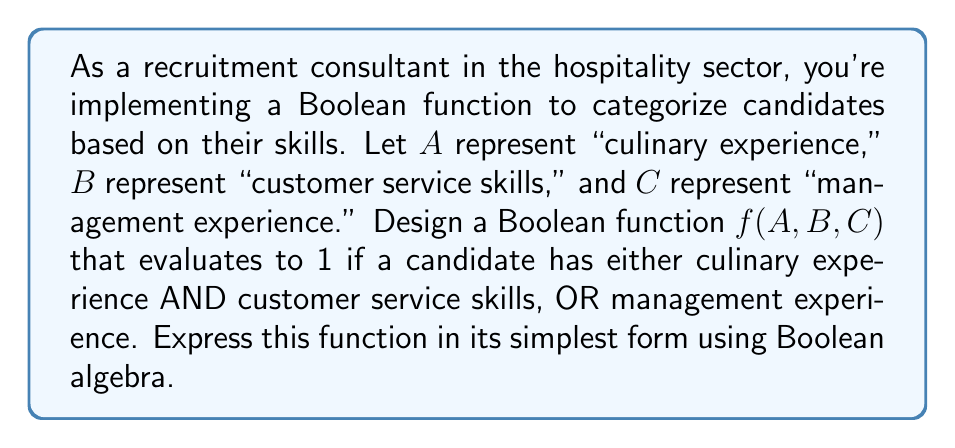Teach me how to tackle this problem. Let's approach this step-by-step:

1) First, we need to translate the given conditions into a Boolean expression:
   - Culinary experience AND customer service skills: $A \cdot B$
   - OR management experience: $C$

2) Combining these, we get:
   $f(A,B,C) = (A \cdot B) + C$

3) This expression is already in its simplest form, as it cannot be reduced further using Boolean algebra laws. Let's verify:

   - We can't apply the distributive law as there's no common term.
   - We can't apply absorption law as $C$ is not a subset of $A \cdot B$.
   - We can't apply complementation as we don't have any negated terms.

4) Therefore, the function $f(A,B,C) = (A \cdot B) + C$ is the simplest form that satisfies the given conditions.

This Boolean function will evaluate to 1 (true) if:
   - A candidate has both culinary experience AND customer service skills, OR
   - A candidate has management experience, OR
   - A candidate has all three qualifications.

It will evaluate to 0 (false) only if a candidate lacks management experience AND either lacks culinary experience OR customer service skills.
Answer: $f(A,B,C) = (A \cdot B) + C$ 